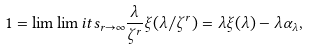<formula> <loc_0><loc_0><loc_500><loc_500>1 = \lim \lim i t s _ { r \to \infty } \frac { \lambda } { \zeta ^ { r } } \xi ( \lambda / \zeta ^ { r } ) = \lambda \xi ( \lambda ) - \lambda \alpha _ { \lambda } ,</formula> 